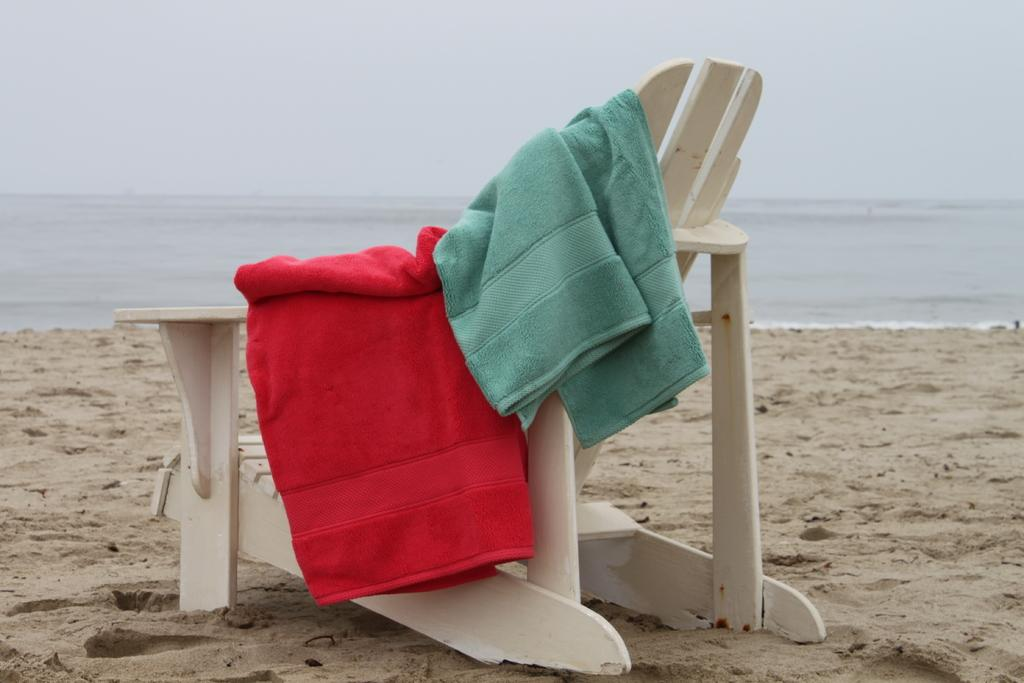What is present on the chair in the image? There are two towels on the chair, one red and one green. What is the chair placed on in the image? The chair is on sand. What can be seen in the background of the image? There is water and the sky visible in the background of the image. What type of location might this be? The location is likely a beach, given the presence of sand and water. Can you see the passenger's toes in the image? There is no passenger present in the image, so it is not possible to see their toes. 